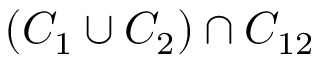Convert formula to latex. <formula><loc_0><loc_0><loc_500><loc_500>( C _ { 1 } \cup C _ { 2 } ) \cap C _ { 1 2 }</formula> 